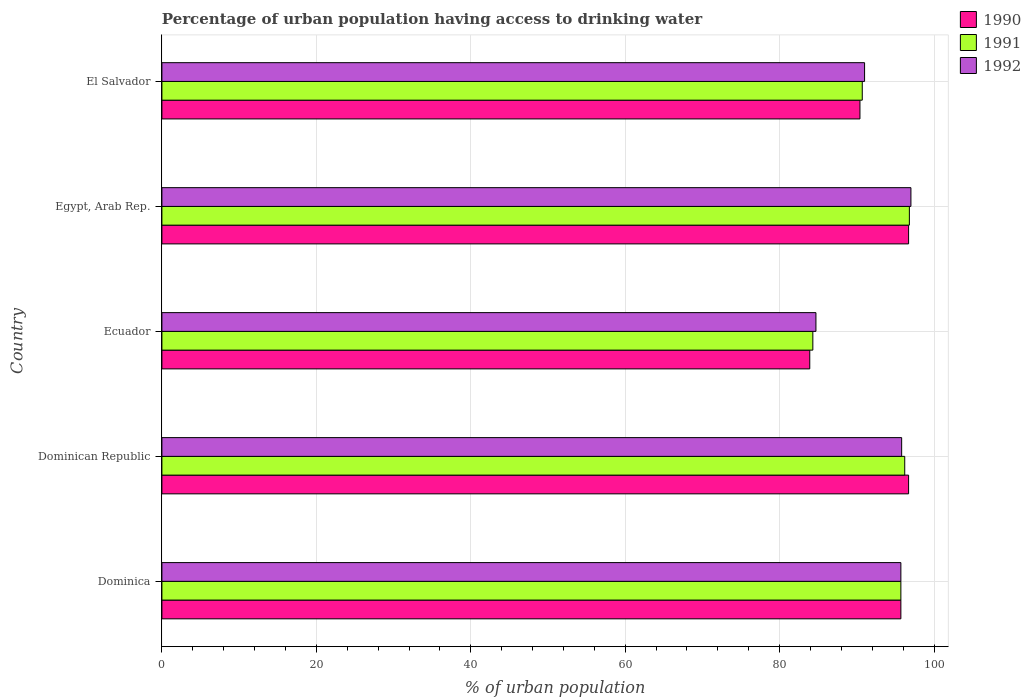How many different coloured bars are there?
Provide a short and direct response. 3. How many groups of bars are there?
Offer a terse response. 5. How many bars are there on the 4th tick from the top?
Your answer should be compact. 3. What is the label of the 4th group of bars from the top?
Offer a very short reply. Dominican Republic. What is the percentage of urban population having access to drinking water in 1992 in Dominica?
Provide a succinct answer. 95.7. Across all countries, what is the maximum percentage of urban population having access to drinking water in 1992?
Offer a terse response. 97. Across all countries, what is the minimum percentage of urban population having access to drinking water in 1992?
Make the answer very short. 84.7. In which country was the percentage of urban population having access to drinking water in 1991 maximum?
Your response must be concise. Egypt, Arab Rep. In which country was the percentage of urban population having access to drinking water in 1991 minimum?
Make the answer very short. Ecuador. What is the total percentage of urban population having access to drinking water in 1992 in the graph?
Make the answer very short. 464.2. What is the difference between the percentage of urban population having access to drinking water in 1991 in Dominican Republic and that in Egypt, Arab Rep.?
Your answer should be very brief. -0.6. What is the difference between the percentage of urban population having access to drinking water in 1992 in El Salvador and the percentage of urban population having access to drinking water in 1990 in Ecuador?
Give a very brief answer. 7.1. What is the average percentage of urban population having access to drinking water in 1991 per country?
Keep it short and to the point. 92.74. What is the difference between the percentage of urban population having access to drinking water in 1990 and percentage of urban population having access to drinking water in 1991 in Ecuador?
Provide a succinct answer. -0.4. In how many countries, is the percentage of urban population having access to drinking water in 1991 greater than 52 %?
Ensure brevity in your answer.  5. What is the ratio of the percentage of urban population having access to drinking water in 1991 in Dominican Republic to that in Egypt, Arab Rep.?
Ensure brevity in your answer.  0.99. Is the percentage of urban population having access to drinking water in 1990 in Dominica less than that in El Salvador?
Your answer should be very brief. No. What is the difference between the highest and the second highest percentage of urban population having access to drinking water in 1992?
Provide a succinct answer. 1.2. What is the difference between the highest and the lowest percentage of urban population having access to drinking water in 1991?
Your response must be concise. 12.5. What does the 1st bar from the top in Dominican Republic represents?
Offer a terse response. 1992. What does the 1st bar from the bottom in El Salvador represents?
Your response must be concise. 1990. Is it the case that in every country, the sum of the percentage of urban population having access to drinking water in 1990 and percentage of urban population having access to drinking water in 1991 is greater than the percentage of urban population having access to drinking water in 1992?
Provide a succinct answer. Yes. Does the graph contain grids?
Your answer should be very brief. Yes. Where does the legend appear in the graph?
Your answer should be compact. Top right. How are the legend labels stacked?
Offer a terse response. Vertical. What is the title of the graph?
Make the answer very short. Percentage of urban population having access to drinking water. What is the label or title of the X-axis?
Your response must be concise. % of urban population. What is the label or title of the Y-axis?
Offer a terse response. Country. What is the % of urban population of 1990 in Dominica?
Your answer should be compact. 95.7. What is the % of urban population of 1991 in Dominica?
Keep it short and to the point. 95.7. What is the % of urban population of 1992 in Dominica?
Keep it short and to the point. 95.7. What is the % of urban population in 1990 in Dominican Republic?
Offer a very short reply. 96.7. What is the % of urban population of 1991 in Dominican Republic?
Your answer should be very brief. 96.2. What is the % of urban population of 1992 in Dominican Republic?
Offer a very short reply. 95.8. What is the % of urban population of 1990 in Ecuador?
Your response must be concise. 83.9. What is the % of urban population of 1991 in Ecuador?
Give a very brief answer. 84.3. What is the % of urban population in 1992 in Ecuador?
Make the answer very short. 84.7. What is the % of urban population in 1990 in Egypt, Arab Rep.?
Provide a succinct answer. 96.7. What is the % of urban population in 1991 in Egypt, Arab Rep.?
Provide a succinct answer. 96.8. What is the % of urban population in 1992 in Egypt, Arab Rep.?
Provide a short and direct response. 97. What is the % of urban population of 1990 in El Salvador?
Keep it short and to the point. 90.4. What is the % of urban population in 1991 in El Salvador?
Your answer should be compact. 90.7. What is the % of urban population in 1992 in El Salvador?
Keep it short and to the point. 91. Across all countries, what is the maximum % of urban population of 1990?
Provide a short and direct response. 96.7. Across all countries, what is the maximum % of urban population of 1991?
Your response must be concise. 96.8. Across all countries, what is the maximum % of urban population in 1992?
Keep it short and to the point. 97. Across all countries, what is the minimum % of urban population of 1990?
Your response must be concise. 83.9. Across all countries, what is the minimum % of urban population of 1991?
Give a very brief answer. 84.3. Across all countries, what is the minimum % of urban population of 1992?
Make the answer very short. 84.7. What is the total % of urban population in 1990 in the graph?
Provide a succinct answer. 463.4. What is the total % of urban population of 1991 in the graph?
Your response must be concise. 463.7. What is the total % of urban population in 1992 in the graph?
Give a very brief answer. 464.2. What is the difference between the % of urban population of 1992 in Dominica and that in Dominican Republic?
Your answer should be very brief. -0.1. What is the difference between the % of urban population in 1990 in Dominica and that in Ecuador?
Make the answer very short. 11.8. What is the difference between the % of urban population in 1991 in Dominica and that in Ecuador?
Ensure brevity in your answer.  11.4. What is the difference between the % of urban population in 1992 in Dominica and that in Ecuador?
Keep it short and to the point. 11. What is the difference between the % of urban population in 1990 in Dominica and that in Egypt, Arab Rep.?
Your answer should be compact. -1. What is the difference between the % of urban population of 1991 in Dominica and that in Egypt, Arab Rep.?
Your answer should be very brief. -1.1. What is the difference between the % of urban population in 1990 in Dominica and that in El Salvador?
Give a very brief answer. 5.3. What is the difference between the % of urban population in 1992 in Dominica and that in El Salvador?
Your answer should be compact. 4.7. What is the difference between the % of urban population in 1990 in Dominican Republic and that in Ecuador?
Offer a terse response. 12.8. What is the difference between the % of urban population of 1990 in Dominican Republic and that in Egypt, Arab Rep.?
Make the answer very short. 0. What is the difference between the % of urban population of 1991 in Dominican Republic and that in Egypt, Arab Rep.?
Your answer should be compact. -0.6. What is the difference between the % of urban population of 1990 in Dominican Republic and that in El Salvador?
Keep it short and to the point. 6.3. What is the difference between the % of urban population of 1992 in Ecuador and that in Egypt, Arab Rep.?
Keep it short and to the point. -12.3. What is the difference between the % of urban population in 1991 in Ecuador and that in El Salvador?
Give a very brief answer. -6.4. What is the difference between the % of urban population in 1992 in Ecuador and that in El Salvador?
Give a very brief answer. -6.3. What is the difference between the % of urban population in 1991 in Egypt, Arab Rep. and that in El Salvador?
Make the answer very short. 6.1. What is the difference between the % of urban population of 1992 in Egypt, Arab Rep. and that in El Salvador?
Your answer should be very brief. 6. What is the difference between the % of urban population in 1991 in Dominica and the % of urban population in 1992 in Dominican Republic?
Give a very brief answer. -0.1. What is the difference between the % of urban population of 1990 in Dominica and the % of urban population of 1991 in Ecuador?
Provide a short and direct response. 11.4. What is the difference between the % of urban population of 1990 in Dominica and the % of urban population of 1992 in Ecuador?
Your answer should be compact. 11. What is the difference between the % of urban population of 1991 in Dominica and the % of urban population of 1992 in Ecuador?
Your answer should be compact. 11. What is the difference between the % of urban population of 1990 in Dominica and the % of urban population of 1991 in Egypt, Arab Rep.?
Your answer should be compact. -1.1. What is the difference between the % of urban population of 1990 in Dominica and the % of urban population of 1992 in Egypt, Arab Rep.?
Your answer should be very brief. -1.3. What is the difference between the % of urban population of 1991 in Dominica and the % of urban population of 1992 in Egypt, Arab Rep.?
Keep it short and to the point. -1.3. What is the difference between the % of urban population of 1990 in Dominica and the % of urban population of 1992 in El Salvador?
Offer a very short reply. 4.7. What is the difference between the % of urban population of 1991 in Dominica and the % of urban population of 1992 in El Salvador?
Your answer should be very brief. 4.7. What is the difference between the % of urban population in 1990 in Dominican Republic and the % of urban population in 1992 in Ecuador?
Offer a very short reply. 12. What is the difference between the % of urban population in 1990 in Dominican Republic and the % of urban population in 1992 in Egypt, Arab Rep.?
Provide a succinct answer. -0.3. What is the difference between the % of urban population of 1990 in Ecuador and the % of urban population of 1992 in Egypt, Arab Rep.?
Provide a succinct answer. -13.1. What is the difference between the % of urban population in 1991 in Ecuador and the % of urban population in 1992 in Egypt, Arab Rep.?
Make the answer very short. -12.7. What is the difference between the % of urban population of 1990 in Ecuador and the % of urban population of 1991 in El Salvador?
Offer a terse response. -6.8. What is the difference between the % of urban population in 1991 in Egypt, Arab Rep. and the % of urban population in 1992 in El Salvador?
Your response must be concise. 5.8. What is the average % of urban population of 1990 per country?
Offer a very short reply. 92.68. What is the average % of urban population in 1991 per country?
Ensure brevity in your answer.  92.74. What is the average % of urban population in 1992 per country?
Offer a very short reply. 92.84. What is the difference between the % of urban population of 1991 and % of urban population of 1992 in Dominican Republic?
Make the answer very short. 0.4. What is the difference between the % of urban population in 1990 and % of urban population in 1991 in Ecuador?
Make the answer very short. -0.4. What is the difference between the % of urban population in 1990 and % of urban population in 1992 in Ecuador?
Your response must be concise. -0.8. What is the difference between the % of urban population in 1991 and % of urban population in 1992 in Ecuador?
Provide a short and direct response. -0.4. What is the difference between the % of urban population in 1990 and % of urban population in 1992 in Egypt, Arab Rep.?
Ensure brevity in your answer.  -0.3. What is the difference between the % of urban population in 1991 and % of urban population in 1992 in Egypt, Arab Rep.?
Give a very brief answer. -0.2. What is the ratio of the % of urban population in 1990 in Dominica to that in Dominican Republic?
Make the answer very short. 0.99. What is the ratio of the % of urban population in 1992 in Dominica to that in Dominican Republic?
Provide a succinct answer. 1. What is the ratio of the % of urban population of 1990 in Dominica to that in Ecuador?
Your answer should be very brief. 1.14. What is the ratio of the % of urban population in 1991 in Dominica to that in Ecuador?
Your answer should be compact. 1.14. What is the ratio of the % of urban population of 1992 in Dominica to that in Ecuador?
Provide a succinct answer. 1.13. What is the ratio of the % of urban population in 1990 in Dominica to that in Egypt, Arab Rep.?
Offer a very short reply. 0.99. What is the ratio of the % of urban population of 1991 in Dominica to that in Egypt, Arab Rep.?
Your answer should be very brief. 0.99. What is the ratio of the % of urban population in 1992 in Dominica to that in Egypt, Arab Rep.?
Keep it short and to the point. 0.99. What is the ratio of the % of urban population of 1990 in Dominica to that in El Salvador?
Provide a short and direct response. 1.06. What is the ratio of the % of urban population in 1991 in Dominica to that in El Salvador?
Ensure brevity in your answer.  1.06. What is the ratio of the % of urban population in 1992 in Dominica to that in El Salvador?
Your answer should be very brief. 1.05. What is the ratio of the % of urban population of 1990 in Dominican Republic to that in Ecuador?
Your answer should be compact. 1.15. What is the ratio of the % of urban population in 1991 in Dominican Republic to that in Ecuador?
Offer a terse response. 1.14. What is the ratio of the % of urban population in 1992 in Dominican Republic to that in Ecuador?
Provide a short and direct response. 1.13. What is the ratio of the % of urban population in 1991 in Dominican Republic to that in Egypt, Arab Rep.?
Keep it short and to the point. 0.99. What is the ratio of the % of urban population in 1992 in Dominican Republic to that in Egypt, Arab Rep.?
Provide a short and direct response. 0.99. What is the ratio of the % of urban population of 1990 in Dominican Republic to that in El Salvador?
Your answer should be compact. 1.07. What is the ratio of the % of urban population of 1991 in Dominican Republic to that in El Salvador?
Ensure brevity in your answer.  1.06. What is the ratio of the % of urban population of 1992 in Dominican Republic to that in El Salvador?
Your response must be concise. 1.05. What is the ratio of the % of urban population of 1990 in Ecuador to that in Egypt, Arab Rep.?
Offer a very short reply. 0.87. What is the ratio of the % of urban population in 1991 in Ecuador to that in Egypt, Arab Rep.?
Give a very brief answer. 0.87. What is the ratio of the % of urban population of 1992 in Ecuador to that in Egypt, Arab Rep.?
Your answer should be very brief. 0.87. What is the ratio of the % of urban population of 1990 in Ecuador to that in El Salvador?
Offer a terse response. 0.93. What is the ratio of the % of urban population in 1991 in Ecuador to that in El Salvador?
Offer a terse response. 0.93. What is the ratio of the % of urban population of 1992 in Ecuador to that in El Salvador?
Provide a short and direct response. 0.93. What is the ratio of the % of urban population of 1990 in Egypt, Arab Rep. to that in El Salvador?
Ensure brevity in your answer.  1.07. What is the ratio of the % of urban population in 1991 in Egypt, Arab Rep. to that in El Salvador?
Give a very brief answer. 1.07. What is the ratio of the % of urban population in 1992 in Egypt, Arab Rep. to that in El Salvador?
Give a very brief answer. 1.07. What is the difference between the highest and the second highest % of urban population in 1992?
Give a very brief answer. 1.2. What is the difference between the highest and the lowest % of urban population of 1990?
Make the answer very short. 12.8. 